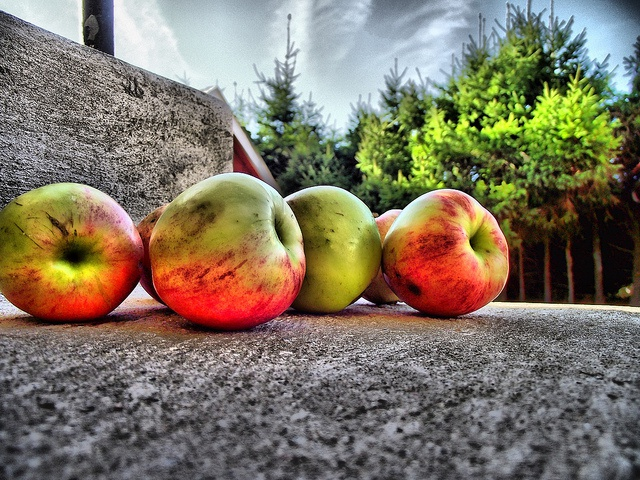Describe the objects in this image and their specific colors. I can see apple in lightgray, red, and olive tones, apple in lightgray, olive, and maroon tones, apple in lightgray, brown, red, maroon, and orange tones, apple in lightgray, olive, and black tones, and apple in lightgray, black, maroon, lavender, and tan tones in this image. 